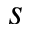<formula> <loc_0><loc_0><loc_500><loc_500>s</formula> 